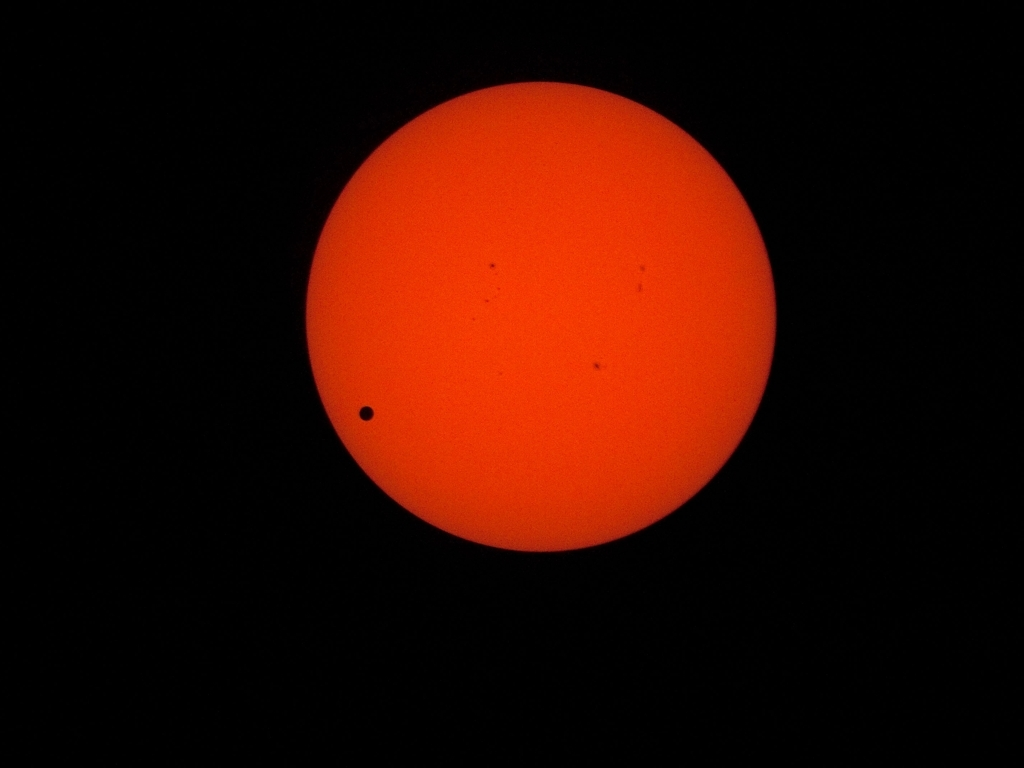Are there any quality issues with this image? While the image does appear to be focused and the subject is clearly visible, it presents a noticeable amount of graininess and a lack of sharp detail which could be due to the high ISO setting or low light conditions. The framing is simple and effective for the subject matter, featuring what appears to be a celestial body with a smaller silhouette against it, likely a solar eclipse or a transit of a planet across the sun. Overall, it serves its purpose but could be improved with higher resolution and better noise reduction techniques. 